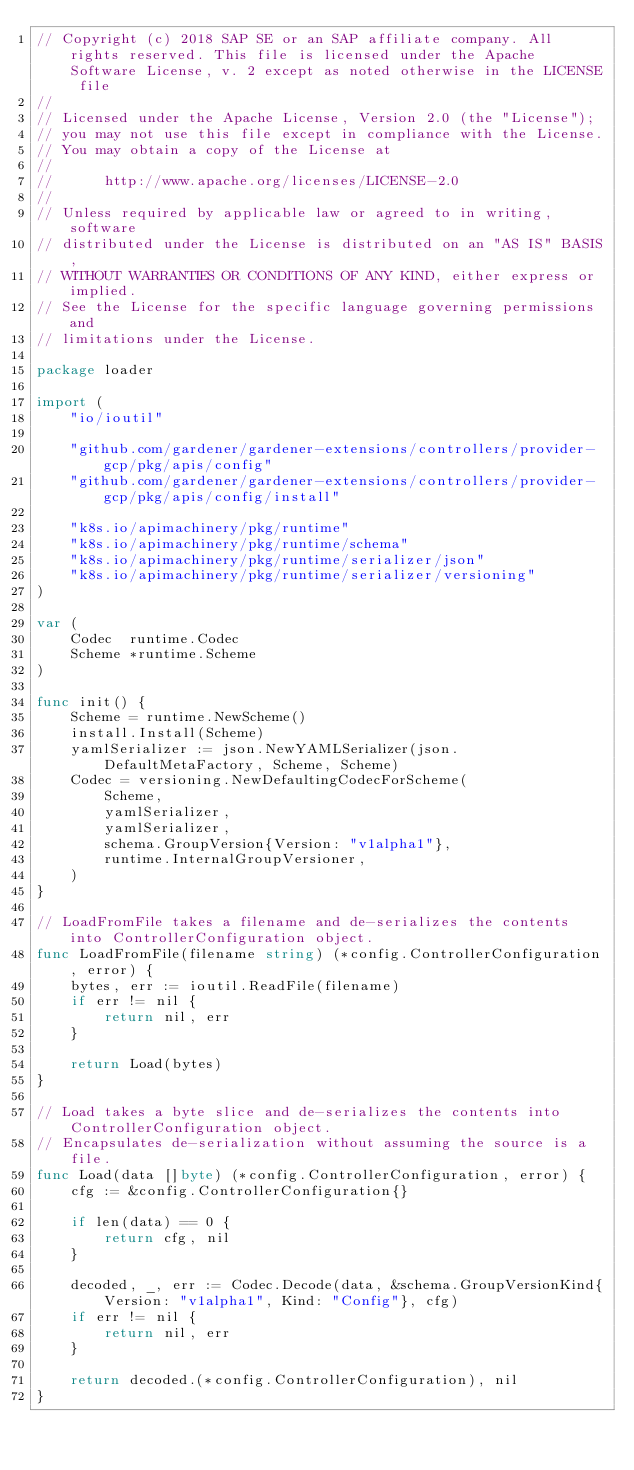Convert code to text. <code><loc_0><loc_0><loc_500><loc_500><_Go_>// Copyright (c) 2018 SAP SE or an SAP affiliate company. All rights reserved. This file is licensed under the Apache Software License, v. 2 except as noted otherwise in the LICENSE file
//
// Licensed under the Apache License, Version 2.0 (the "License");
// you may not use this file except in compliance with the License.
// You may obtain a copy of the License at
//
//      http://www.apache.org/licenses/LICENSE-2.0
//
// Unless required by applicable law or agreed to in writing, software
// distributed under the License is distributed on an "AS IS" BASIS,
// WITHOUT WARRANTIES OR CONDITIONS OF ANY KIND, either express or implied.
// See the License for the specific language governing permissions and
// limitations under the License.

package loader

import (
	"io/ioutil"

	"github.com/gardener/gardener-extensions/controllers/provider-gcp/pkg/apis/config"
	"github.com/gardener/gardener-extensions/controllers/provider-gcp/pkg/apis/config/install"

	"k8s.io/apimachinery/pkg/runtime"
	"k8s.io/apimachinery/pkg/runtime/schema"
	"k8s.io/apimachinery/pkg/runtime/serializer/json"
	"k8s.io/apimachinery/pkg/runtime/serializer/versioning"
)

var (
	Codec  runtime.Codec
	Scheme *runtime.Scheme
)

func init() {
	Scheme = runtime.NewScheme()
	install.Install(Scheme)
	yamlSerializer := json.NewYAMLSerializer(json.DefaultMetaFactory, Scheme, Scheme)
	Codec = versioning.NewDefaultingCodecForScheme(
		Scheme,
		yamlSerializer,
		yamlSerializer,
		schema.GroupVersion{Version: "v1alpha1"},
		runtime.InternalGroupVersioner,
	)
}

// LoadFromFile takes a filename and de-serializes the contents into ControllerConfiguration object.
func LoadFromFile(filename string) (*config.ControllerConfiguration, error) {
	bytes, err := ioutil.ReadFile(filename)
	if err != nil {
		return nil, err
	}

	return Load(bytes)
}

// Load takes a byte slice and de-serializes the contents into ControllerConfiguration object.
// Encapsulates de-serialization without assuming the source is a file.
func Load(data []byte) (*config.ControllerConfiguration, error) {
	cfg := &config.ControllerConfiguration{}

	if len(data) == 0 {
		return cfg, nil
	}

	decoded, _, err := Codec.Decode(data, &schema.GroupVersionKind{Version: "v1alpha1", Kind: "Config"}, cfg)
	if err != nil {
		return nil, err
	}

	return decoded.(*config.ControllerConfiguration), nil
}
</code> 